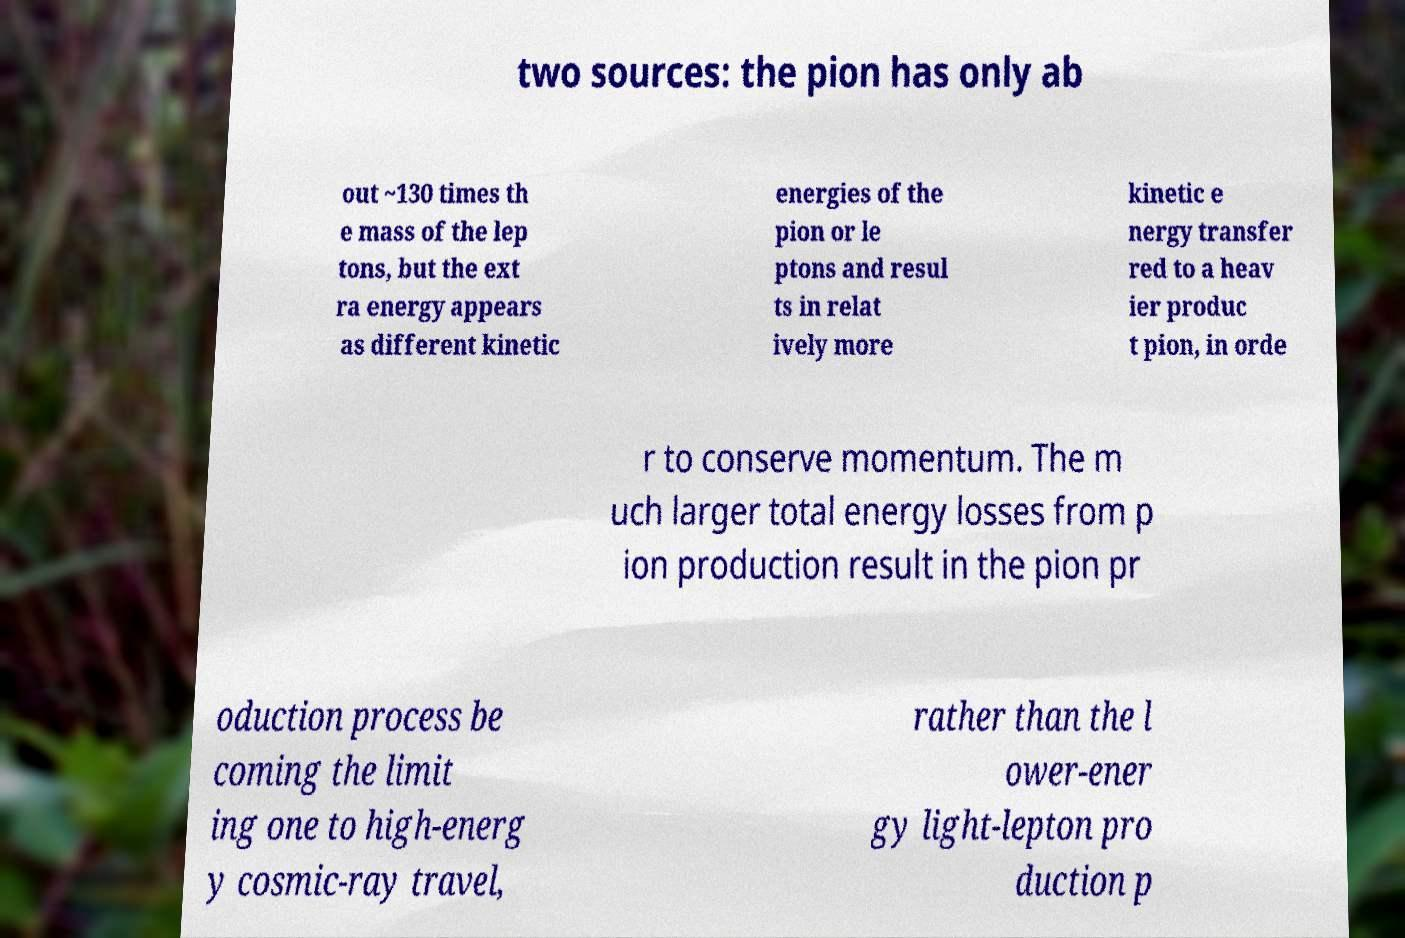Please read and relay the text visible in this image. What does it say? two sources: the pion has only ab out ~130 times th e mass of the lep tons, but the ext ra energy appears as different kinetic energies of the pion or le ptons and resul ts in relat ively more kinetic e nergy transfer red to a heav ier produc t pion, in orde r to conserve momentum. The m uch larger total energy losses from p ion production result in the pion pr oduction process be coming the limit ing one to high-energ y cosmic-ray travel, rather than the l ower-ener gy light-lepton pro duction p 